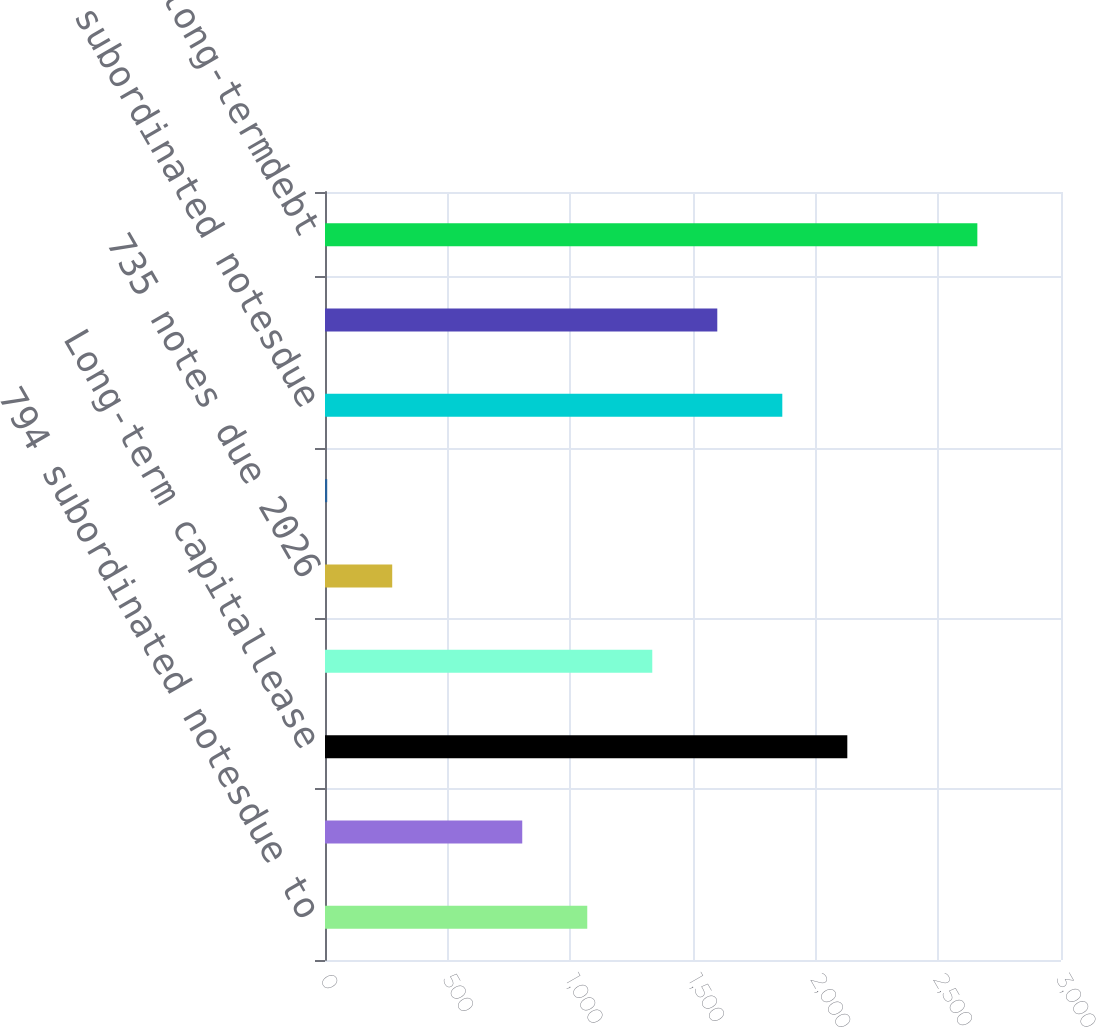Convert chart. <chart><loc_0><loc_0><loc_500><loc_500><bar_chart><fcel>794 subordinated notesdue to<fcel>Floatingrate subordinated<fcel>Long-term capitallease<fcel>765 subordinated notesdue<fcel>735 notes due 2026<fcel>950mortgage note due 2009<fcel>525 subordinated notesdue<fcel>530 subordinated notesdue 2016<fcel>Total long-termdebt<nl><fcel>1069<fcel>804<fcel>2129<fcel>1334<fcel>274<fcel>9<fcel>1864<fcel>1599<fcel>2659<nl></chart> 